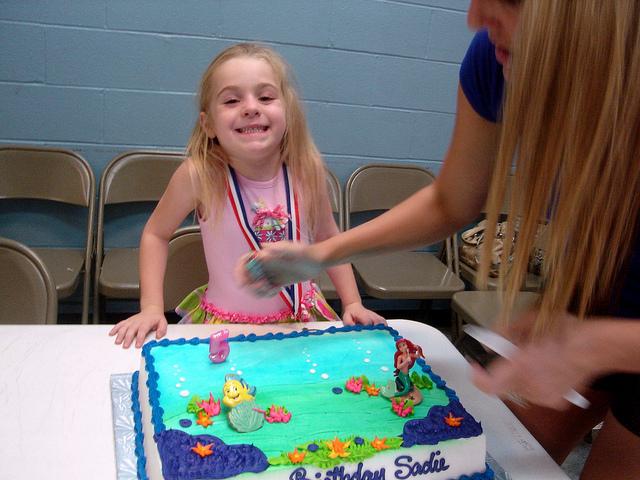Is this a birthday cake?
Concise answer only. Yes. What does the writing say on the cake?
Be succinct. Birthday sadie. How many children are there?
Keep it brief. 1. What is the theme of the picture?
Short answer required. Birthday. Is the girl happy?
Quick response, please. Yes. 